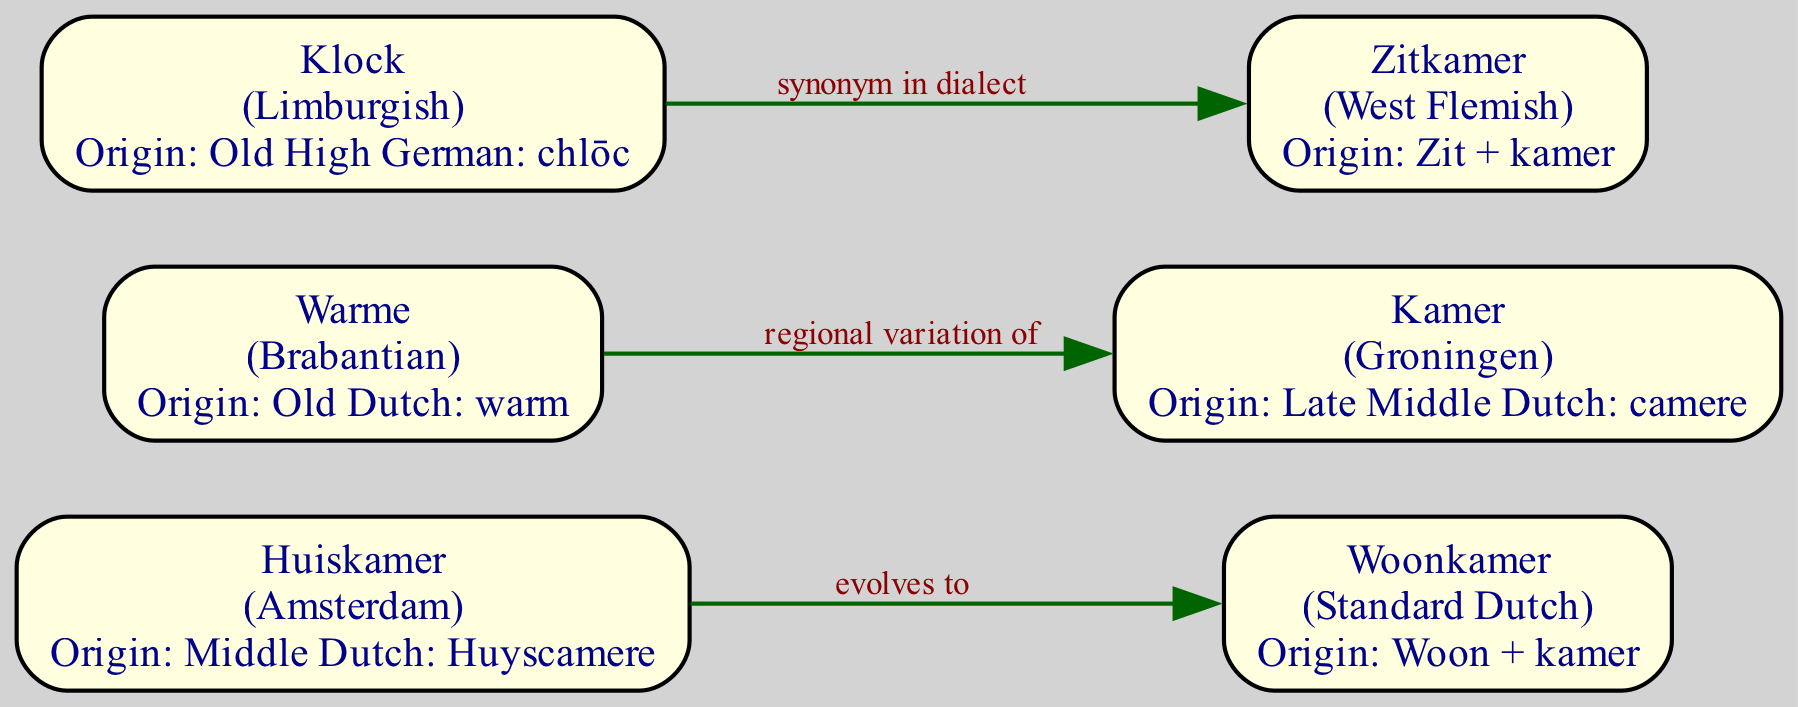What is the dialect associated with the label "Huiskamer"? The label "Huiskamer" is associated with the dialect "Amsterdam" as indicated in the node information.
Answer: Amsterdam How many nodes are present in the diagram? The diagram has a total of six nodes, as counted in the data provided under the 'nodes' section.
Answer: 6 What is the relation between "Kamer" and "Zitkamer"? The relation between "Kamer" and "Zitkamer" is "synonym in dialect," as depicted by the edge connecting these two nodes.
Answer: synonym in dialect Which term evolves to "Woonkamer"? The term "Huiskamer" evolves to "Woonkamer," as indicated by the directed edge from node 1 to node 2.
Answer: Huiskamer What is the origin of the term "Warme"? The origin of the term "Warme" is "Old Dutch: warm," as mentioned in the node details.
Answer: Old Dutch: warm What is the relationship between "Warme" and "Kamer"? The relationship is that "Warme" is a regional variation of "Kamer," based on the edge that connects them indicating this specific relationship.
Answer: regional variation of Which dialect has the origin "Old High German: chlōc"? The dialect with the origin "Old High German: chlōc" is "Limburgish," which is specified in the nodes data.
Answer: Limburgish Which node has the most recent term evolution? The most recent term evolution can be found in the edge from "Huiskamer" to "Woonkamer" as it suggests a direct evolution to a more contemporary term in Standard Dutch.
Answer: Huiskamer What happens to "Klock" in the graph? "Klock" becomes a synonym in dialect to "Zitkamer," shown as a directed edge from node 5 to node 6 indicating this relationship.
Answer: becomes a synonym in dialect to Zitkamer 